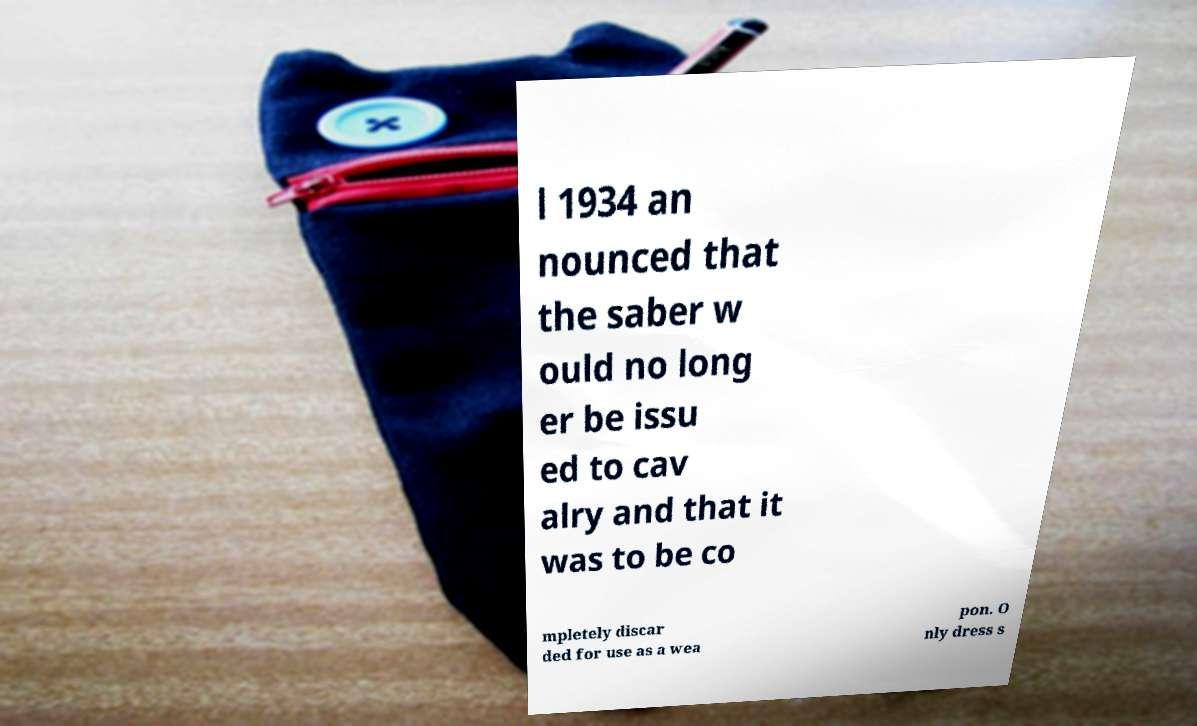Can you read and provide the text displayed in the image?This photo seems to have some interesting text. Can you extract and type it out for me? l 1934 an nounced that the saber w ould no long er be issu ed to cav alry and that it was to be co mpletely discar ded for use as a wea pon. O nly dress s 